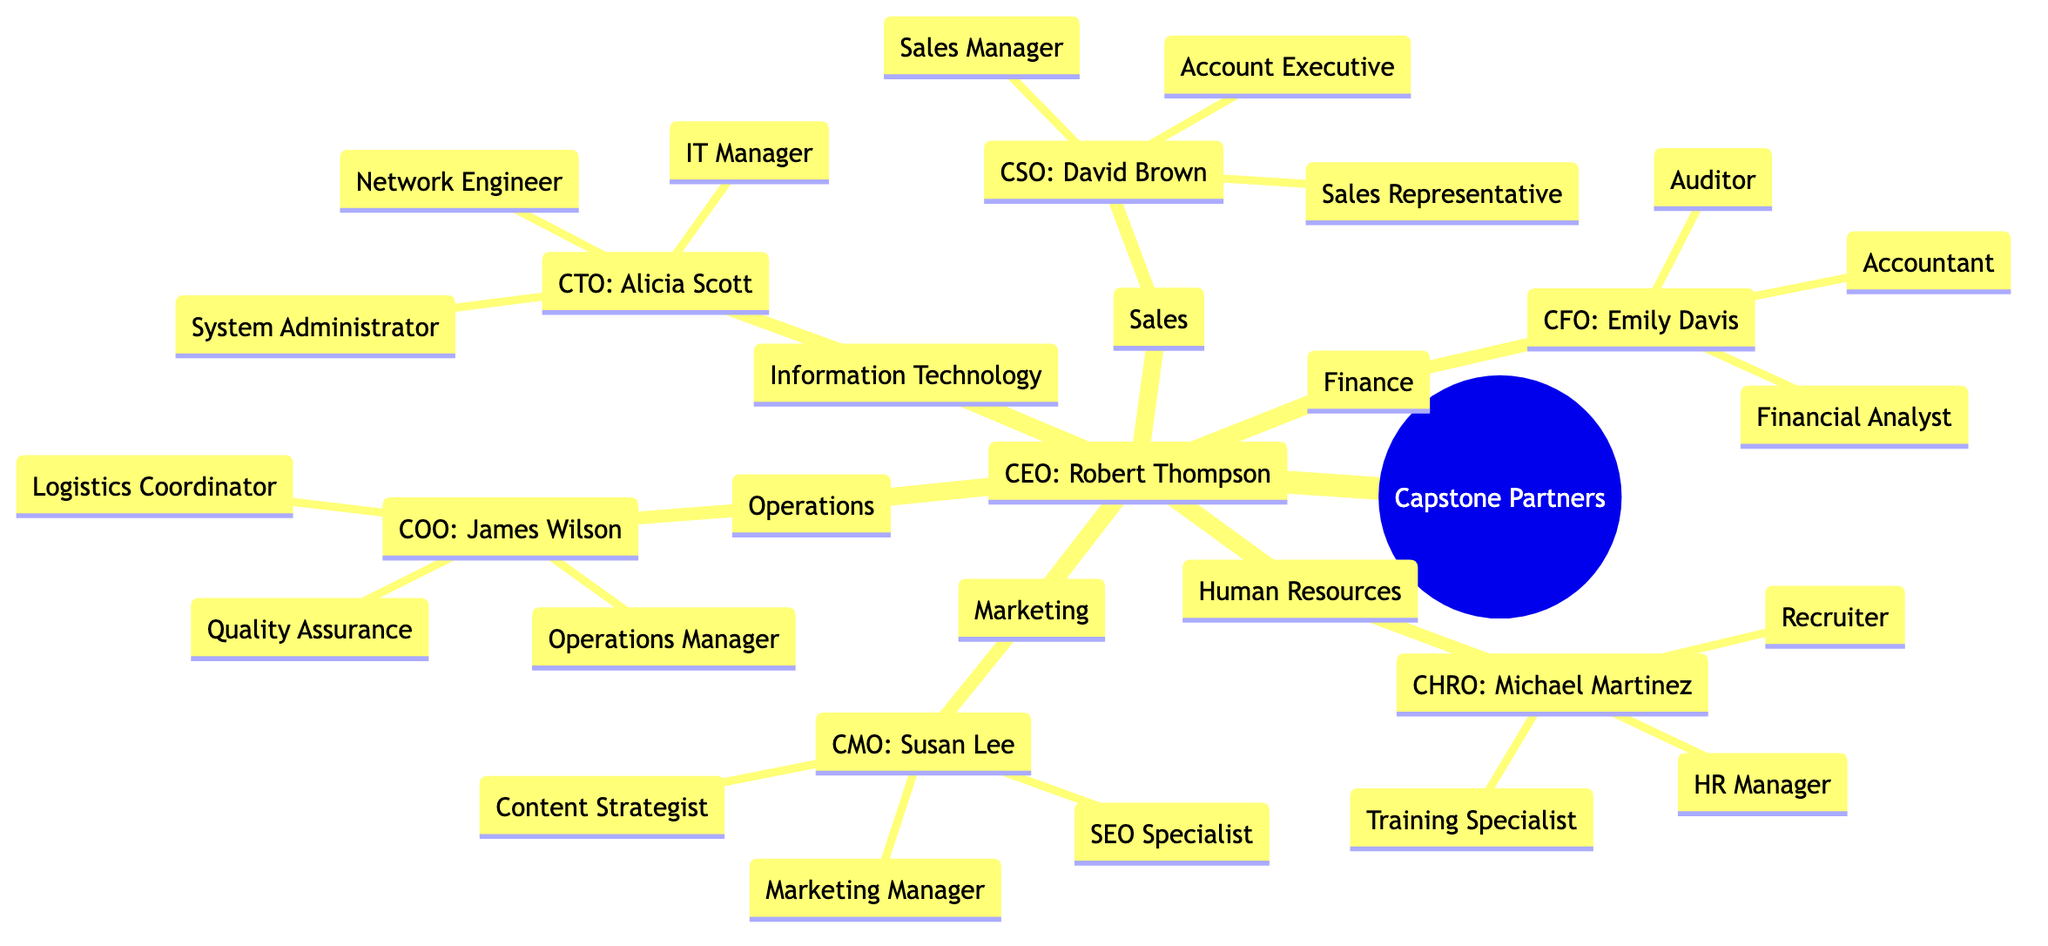What is the title of the head of the Marketing department? The diagram shows that the head of the Marketing department is labeled as CMO, which stands for Chief Marketing Officer.
Answer: CMO How many departments report directly to the CEO? By examining the diagram, we can see that there are six departments listed under the CEO.
Answer: 6 Who is responsible for Human Resources? The diagram indicates that the CHRO, Chief Human Resources Officer, is in charge of the Human Resources department, and the person's name is Michael Martinez.
Answer: Michael Martinez What role is found in the Operations department? The diagram lists three roles under the Operations department, and one of them is Operations Manager. This is a direct reading from the Operations section.
Answer: Operations Manager Which department does the IT Manager belong to? From the diagram, we can trace that the IT Manager role is located under the Information Technology department, indicating that it belongs there.
Answer: Information Technology What is the role of the head of the Finance department? The head of the Finance department is the CFO, and since the document specifies that the CFO's role is Chief Financial Officer, we arrive here logically.
Answer: Chief Financial Officer How many roles are listed under the Sales department? The diagram shows three specific roles associated with the Sales department: Sales Manager, Account Executive, and Sales Representative, making the total count three.
Answer: 3 Who oversees the Operations department? By looking at the diagram, we see that the COO, which stands for Chief Operations Officer, oversees the Operations department, and the person holding this title is James Wilson.
Answer: James Wilson In total, how many roles are associated with the Human Resources department? The diagram lists three roles under the Human Resources department: HR Manager, Recruiter, and Training Specialist, leading to a total count of three roles.
Answer: 3 